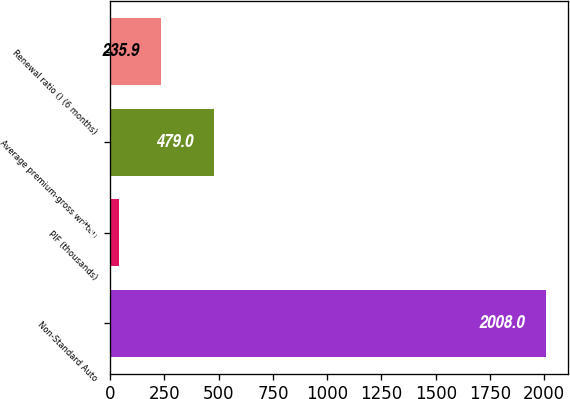<chart> <loc_0><loc_0><loc_500><loc_500><bar_chart><fcel>Non-Standard Auto<fcel>PIF (thousands)<fcel>Average premium-gross written<fcel>Renewal ratio () (6 months)<nl><fcel>2008<fcel>39<fcel>479<fcel>235.9<nl></chart> 